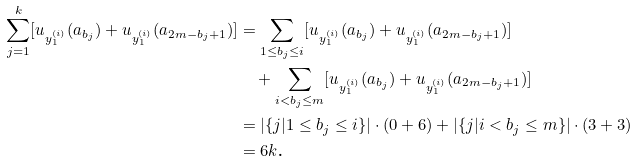<formula> <loc_0><loc_0><loc_500><loc_500>\sum _ { j = 1 } ^ { k } [ u _ { y ^ { ( i ) } _ { 1 } } ( a _ { b _ { j } } ) + u _ { y ^ { ( i ) } _ { 1 } } ( a _ { 2 m - b _ { j } + 1 } ) ] & = \sum _ { 1 \leq b _ { j } \leq i } [ u _ { y ^ { ( i ) } _ { 1 } } ( a _ { b _ { j } } ) + u _ { y ^ { ( i ) } _ { 1 } } ( a _ { 2 m - b _ { j } + 1 } ) ] \\ & \quad + \sum _ { i < b _ { j } \leq m } [ u _ { y ^ { ( i ) } _ { 1 } } ( a _ { b _ { j } } ) + u _ { y ^ { ( i ) } _ { 1 } } ( a _ { 2 m - b _ { j } + 1 } ) ] \\ & = \left | \{ j | 1 \leq b _ { j } \leq i \} \right | \cdot ( 0 + 6 ) + \left | \{ j | i < b _ { j } \leq m \} \right | \cdot ( 3 + 3 ) \\ & = 6 k \text {.}</formula> 